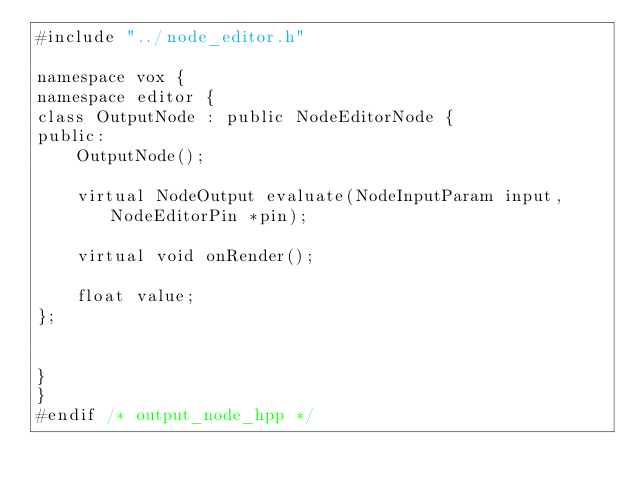Convert code to text. <code><loc_0><loc_0><loc_500><loc_500><_C_>#include "../node_editor.h"

namespace vox {
namespace editor {
class OutputNode : public NodeEditorNode {
public:
    OutputNode();

    virtual NodeOutput evaluate(NodeInputParam input, NodeEditorPin *pin);

    virtual void onRender();

    float value;
};


}
}
#endif /* output_node_hpp */
</code> 